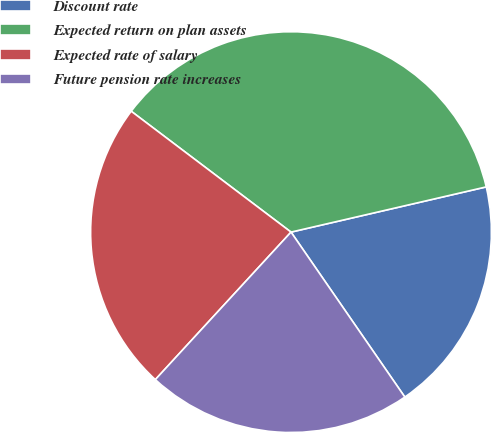Convert chart to OTSL. <chart><loc_0><loc_0><loc_500><loc_500><pie_chart><fcel>Discount rate<fcel>Expected return on plan assets<fcel>Expected rate of salary<fcel>Future pension rate increases<nl><fcel>19.01%<fcel>36.07%<fcel>23.47%<fcel>21.45%<nl></chart> 